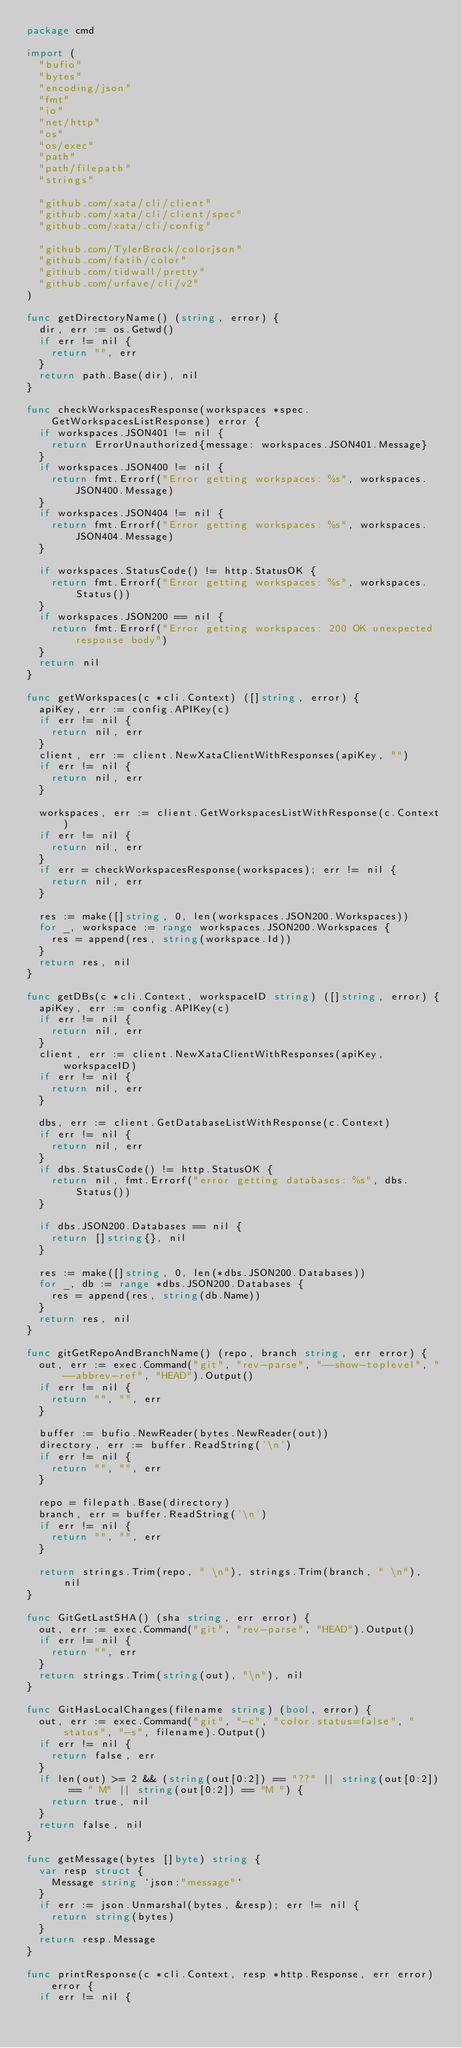Convert code to text. <code><loc_0><loc_0><loc_500><loc_500><_Go_>package cmd

import (
	"bufio"
	"bytes"
	"encoding/json"
	"fmt"
	"io"
	"net/http"
	"os"
	"os/exec"
	"path"
	"path/filepath"
	"strings"

	"github.com/xata/cli/client"
	"github.com/xata/cli/client/spec"
	"github.com/xata/cli/config"

	"github.com/TylerBrock/colorjson"
	"github.com/fatih/color"
	"github.com/tidwall/pretty"
	"github.com/urfave/cli/v2"
)

func getDirectoryName() (string, error) {
	dir, err := os.Getwd()
	if err != nil {
		return "", err
	}
	return path.Base(dir), nil
}

func checkWorkspacesResponse(workspaces *spec.GetWorkspacesListResponse) error {
	if workspaces.JSON401 != nil {
		return ErrorUnauthorized{message: workspaces.JSON401.Message}
	}
	if workspaces.JSON400 != nil {
		return fmt.Errorf("Error getting workspaces: %s", workspaces.JSON400.Message)
	}
	if workspaces.JSON404 != nil {
		return fmt.Errorf("Error getting workspaces: %s", workspaces.JSON404.Message)
	}

	if workspaces.StatusCode() != http.StatusOK {
		return fmt.Errorf("Error getting workspaces: %s", workspaces.Status())
	}
	if workspaces.JSON200 == nil {
		return fmt.Errorf("Error getting workspaces: 200 OK unexpected response body")
	}
	return nil
}

func getWorkspaces(c *cli.Context) ([]string, error) {
	apiKey, err := config.APIKey(c)
	if err != nil {
		return nil, err
	}
	client, err := client.NewXataClientWithResponses(apiKey, "")
	if err != nil {
		return nil, err
	}

	workspaces, err := client.GetWorkspacesListWithResponse(c.Context)
	if err != nil {
		return nil, err
	}
	if err = checkWorkspacesResponse(workspaces); err != nil {
		return nil, err
	}

	res := make([]string, 0, len(workspaces.JSON200.Workspaces))
	for _, workspace := range workspaces.JSON200.Workspaces {
		res = append(res, string(workspace.Id))
	}
	return res, nil
}

func getDBs(c *cli.Context, workspaceID string) ([]string, error) {
	apiKey, err := config.APIKey(c)
	if err != nil {
		return nil, err
	}
	client, err := client.NewXataClientWithResponses(apiKey, workspaceID)
	if err != nil {
		return nil, err
	}

	dbs, err := client.GetDatabaseListWithResponse(c.Context)
	if err != nil {
		return nil, err
	}
	if dbs.StatusCode() != http.StatusOK {
		return nil, fmt.Errorf("error getting databases: %s", dbs.Status())
	}

	if dbs.JSON200.Databases == nil {
		return []string{}, nil
	}

	res := make([]string, 0, len(*dbs.JSON200.Databases))
	for _, db := range *dbs.JSON200.Databases {
		res = append(res, string(db.Name))
	}
	return res, nil
}

func gitGetRepoAndBranchName() (repo, branch string, err error) {
	out, err := exec.Command("git", "rev-parse", "--show-toplevel", "--abbrev-ref", "HEAD").Output()
	if err != nil {
		return "", "", err
	}

	buffer := bufio.NewReader(bytes.NewReader(out))
	directory, err := buffer.ReadString('\n')
	if err != nil {
		return "", "", err
	}

	repo = filepath.Base(directory)
	branch, err = buffer.ReadString('\n')
	if err != nil {
		return "", "", err
	}

	return strings.Trim(repo, " \n"), strings.Trim(branch, " \n"), nil
}

func GitGetLastSHA() (sha string, err error) {
	out, err := exec.Command("git", "rev-parse", "HEAD").Output()
	if err != nil {
		return "", err
	}
	return strings.Trim(string(out), "\n"), nil
}

func GitHasLocalChanges(filename string) (bool, error) {
	out, err := exec.Command("git", "-c", "color.status=false", "status", "-s", filename).Output()
	if err != nil {
		return false, err
	}
	if len(out) >= 2 && (string(out[0:2]) == "??" || string(out[0:2]) == " M" || string(out[0:2]) == "M ") {
		return true, nil
	}
	return false, nil
}

func getMessage(bytes []byte) string {
	var resp struct {
		Message string `json:"message"`
	}
	if err := json.Unmarshal(bytes, &resp); err != nil {
		return string(bytes)
	}
	return resp.Message
}

func printResponse(c *cli.Context, resp *http.Response, err error) error {
	if err != nil {</code> 